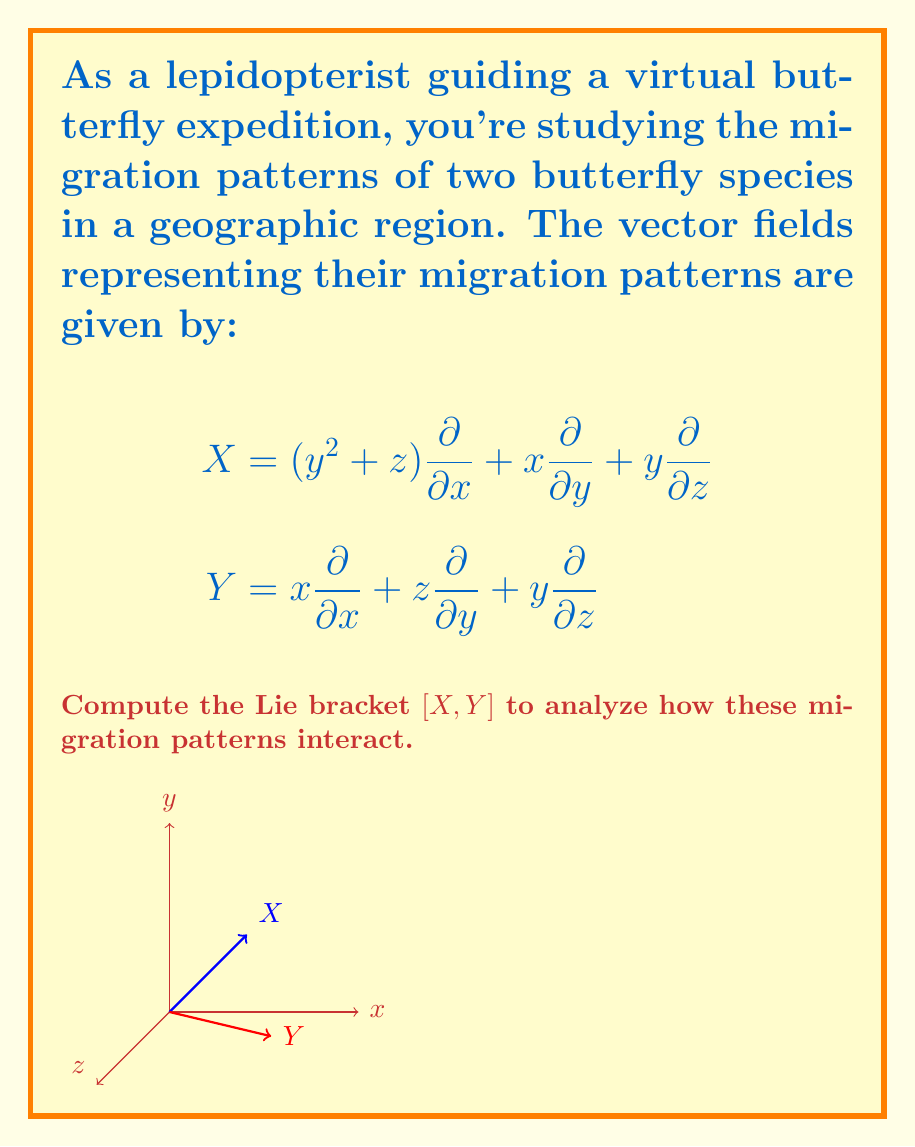Show me your answer to this math problem. To compute the Lie bracket $[X,Y]$, we follow these steps:

1) The Lie bracket is defined as $[X,Y] = XY - YX$, where $X$ and $Y$ are vector fields.

2) First, we need to compute $XY$:
   $X = (y^2 + z)\frac{\partial}{\partial x} + x\frac{\partial}{\partial y} + y\frac{\partial}{\partial z}$
   $Y = x\frac{\partial}{\partial x} + z\frac{\partial}{\partial y} + y\frac{\partial}{\partial z}$

   $XY = (y^2 + z)\frac{\partial}{\partial x}(x) + x\frac{\partial}{\partial y}(z) + y\frac{\partial}{\partial z}(y)$
       $+ (y^2 + z)\frac{\partial}{\partial x} + x\frac{\partial}{\partial y} + y\frac{\partial}{\partial z}$
       $= (y^2 + z) + 0 + y + (y^2 + z)\frac{\partial}{\partial x} + x\frac{\partial}{\partial y} + y\frac{\partial}{\partial z}$

3) Next, we compute $YX$:
   $YX = x\frac{\partial}{\partial x}(y^2 + z) + z\frac{\partial}{\partial y}(x) + y\frac{\partial}{\partial z}(y)$
       $+ x\frac{\partial}{\partial x} + z\frac{\partial}{\partial y} + y\frac{\partial}{\partial z}$
       $= 0 + z + y + x\frac{\partial}{\partial x} + z\frac{\partial}{\partial y} + y\frac{\partial}{\partial z}$

4) Now we can compute $[X,Y] = XY - YX$:
   $[X,Y] = ((y^2 + z) + y + (y^2 + z)\frac{\partial}{\partial x} + x\frac{\partial}{\partial y} + y\frac{\partial}{\partial z})$
          $- (z + y + x\frac{\partial}{\partial x} + z\frac{\partial}{\partial y} + y\frac{\partial}{\partial z})$
   
   $= y^2 + (y^2 + z)\frac{\partial}{\partial x} + x\frac{\partial}{\partial y} - x\frac{\partial}{\partial x} - z\frac{\partial}{\partial y}$

5) Simplifying:
   $[X,Y] = y^2 + (y^2 + z)\frac{\partial}{\partial x} + (x - z)\frac{\partial}{\partial y} - x\frac{\partial}{\partial x}$

This Lie bracket represents how the two migration patterns interact and influence each other in the given geographic region.
Answer: $[X,Y] = y^2 + (y^2 + z)\frac{\partial}{\partial x} + (x - z)\frac{\partial}{\partial y} - x\frac{\partial}{\partial x}$ 